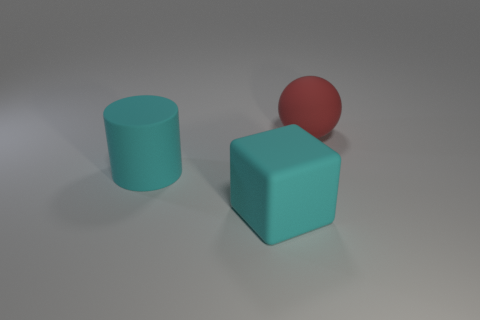Subtract all cubes. How many objects are left? 2 Subtract 0 purple balls. How many objects are left? 3 Subtract all brown cubes. Subtract all cyan spheres. How many cubes are left? 1 Subtract all green cylinders. How many yellow cubes are left? 0 Subtract all large brown metal cylinders. Subtract all big cyan matte blocks. How many objects are left? 2 Add 3 big red rubber spheres. How many big red rubber spheres are left? 4 Add 3 large gray rubber cubes. How many large gray rubber cubes exist? 3 Add 1 large brown shiny cylinders. How many objects exist? 4 